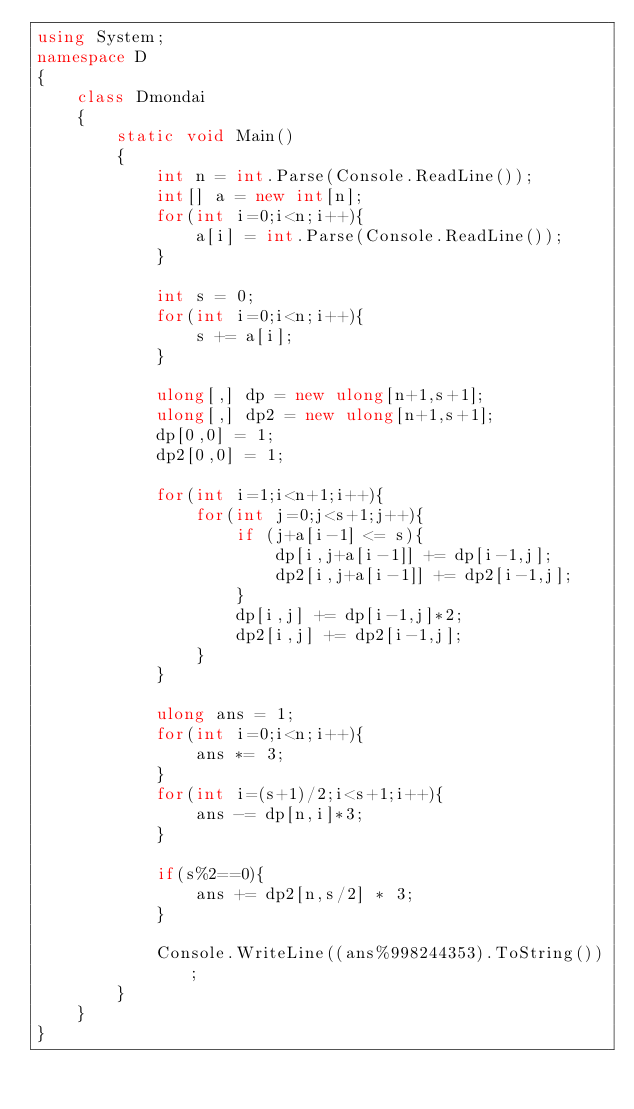Convert code to text. <code><loc_0><loc_0><loc_500><loc_500><_C#_>using System;
namespace D
{
    class Dmondai
    {
        static void Main()
        {
            int n = int.Parse(Console.ReadLine());
            int[] a = new int[n];
            for(int i=0;i<n;i++){
                a[i] = int.Parse(Console.ReadLine());
            }
 
            int s = 0;
            for(int i=0;i<n;i++){
                s += a[i];
            }
 
            ulong[,] dp = new ulong[n+1,s+1];
            ulong[,] dp2 = new ulong[n+1,s+1];
            dp[0,0] = 1;
            dp2[0,0] = 1;
 
            for(int i=1;i<n+1;i++){
                for(int j=0;j<s+1;j++){
                    if (j+a[i-1] <= s){
                        dp[i,j+a[i-1]] += dp[i-1,j];
                        dp2[i,j+a[i-1]] += dp2[i-1,j];
                    }
                    dp[i,j] += dp[i-1,j]*2;
                    dp2[i,j] += dp2[i-1,j];
                }
            }
 
            ulong ans = 1;
            for(int i=0;i<n;i++){
                ans *= 3;
            }
            for(int i=(s+1)/2;i<s+1;i++){
                ans -= dp[n,i]*3;
            }
 
            if(s%2==0){
                ans += dp2[n,s/2] * 3;
            }
 
            Console.WriteLine((ans%998244353).ToString());
        }
    }
}</code> 